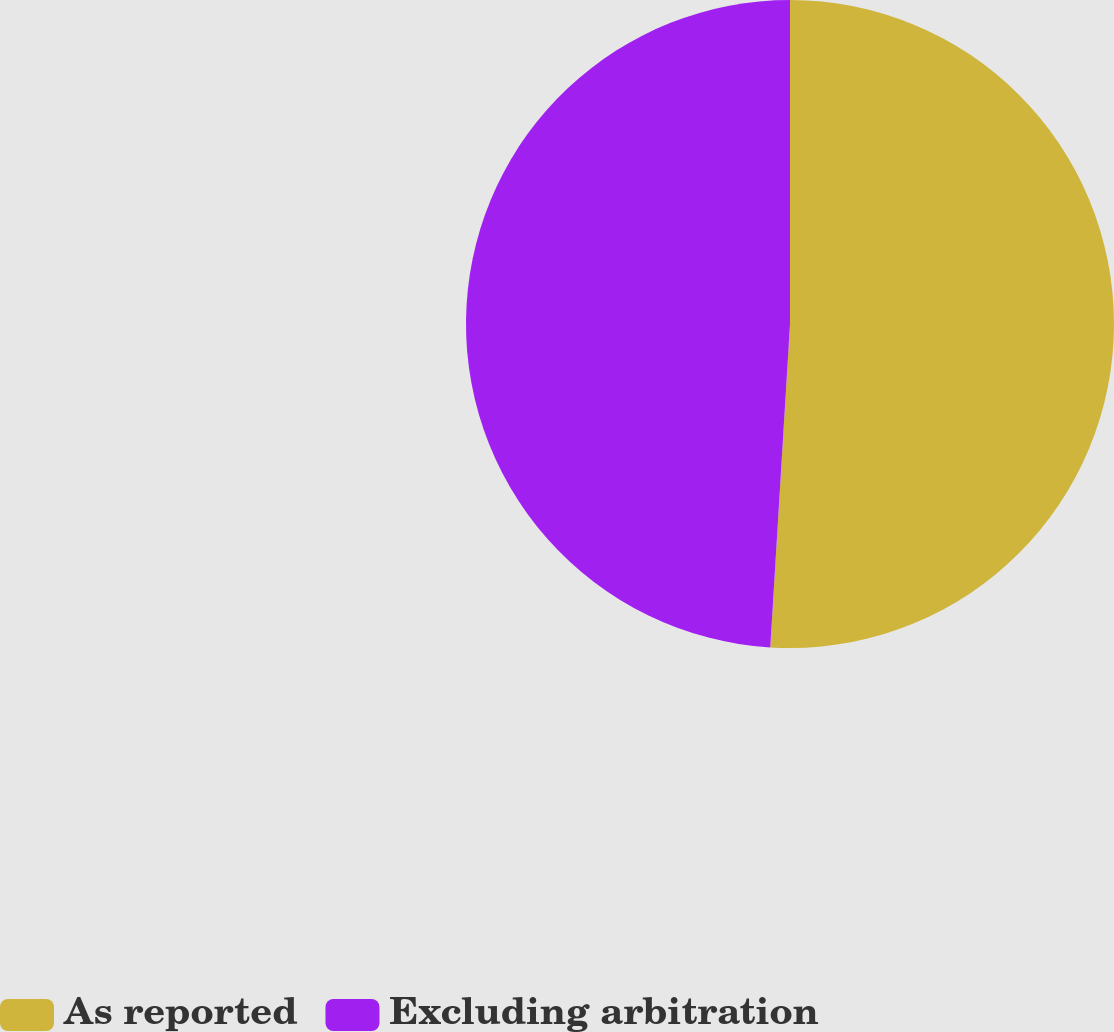<chart> <loc_0><loc_0><loc_500><loc_500><pie_chart><fcel>As reported<fcel>Excluding arbitration<nl><fcel>50.97%<fcel>49.03%<nl></chart> 